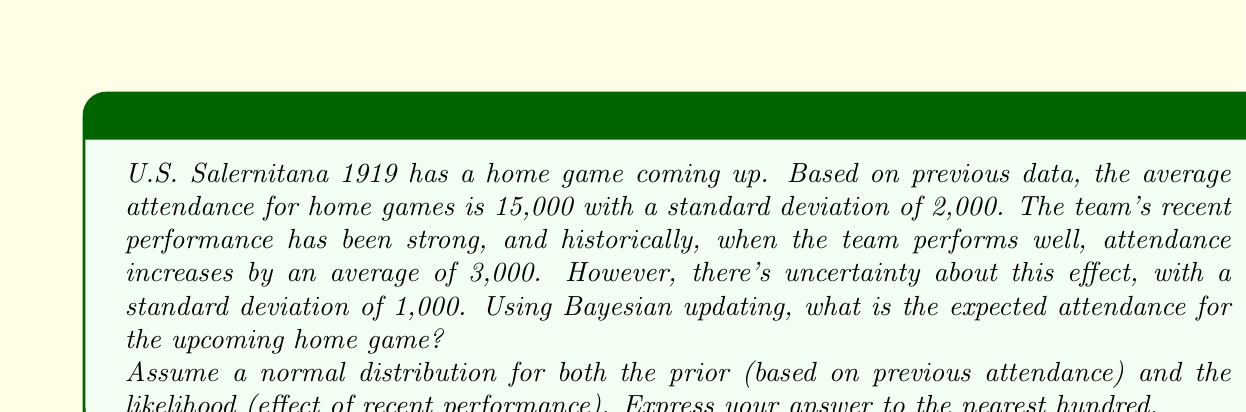What is the answer to this math problem? Let's approach this problem using Bayesian updating with normal distributions:

1) Define our variables:
   $\mu_0 = 15000$ (prior mean)
   $\sigma_0 = 2000$ (prior standard deviation)
   $\mu_1 = 3000$ (likelihood mean)
   $\sigma_1 = 1000$ (likelihood standard deviation)

2) In Bayesian updating with normal distributions, the posterior distribution is also normal. The formulas for the posterior mean ($\mu_p$) and posterior precision ($\tau_p$) are:

   $$\mu_p = \frac{\frac{\mu_0}{\sigma_0^2} + \frac{\mu_1}{\sigma_1^2}}{\frac{1}{\sigma_0^2} + \frac{1}{\sigma_1^2}}$$

   $$\tau_p = \frac{1}{\sigma_0^2} + \frac{1}{\sigma_1^2}$$

3) Let's calculate the posterior precision first:

   $$\tau_p = \frac{1}{2000^2} + \frac{1}{1000^2} = 2.5 \times 10^{-7} + 1 \times 10^{-6} = 1.25 \times 10^{-6}$$

4) Now, let's calculate the numerator and denominator of $\mu_p$ separately:

   Numerator: $\frac{15000}{2000^2} + \frac{3000}{1000^2} = 3.75 \times 10^{-3} + 3 \times 10^{-3} = 6.75 \times 10^{-3}$

   Denominator: $1.25 \times 10^{-6}$ (from step 3)

5) Now we can calculate $\mu_p$:

   $$\mu_p = \frac{6.75 \times 10^{-3}}{1.25 \times 10^{-6}} = 5400$$

6) The posterior standard deviation is the inverse square root of the precision:

   $$\sigma_p = \frac{1}{\sqrt{\tau_p}} = \frac{1}{\sqrt{1.25 \times 10^{-6}}} \approx 894.43$$

7) Therefore, our posterior distribution is normal with mean 17,400 (15,000 + 2,400) and standard deviation approximately 894.

8) The expected value of this distribution is simply its mean, 17,400.
Answer: 17,400 